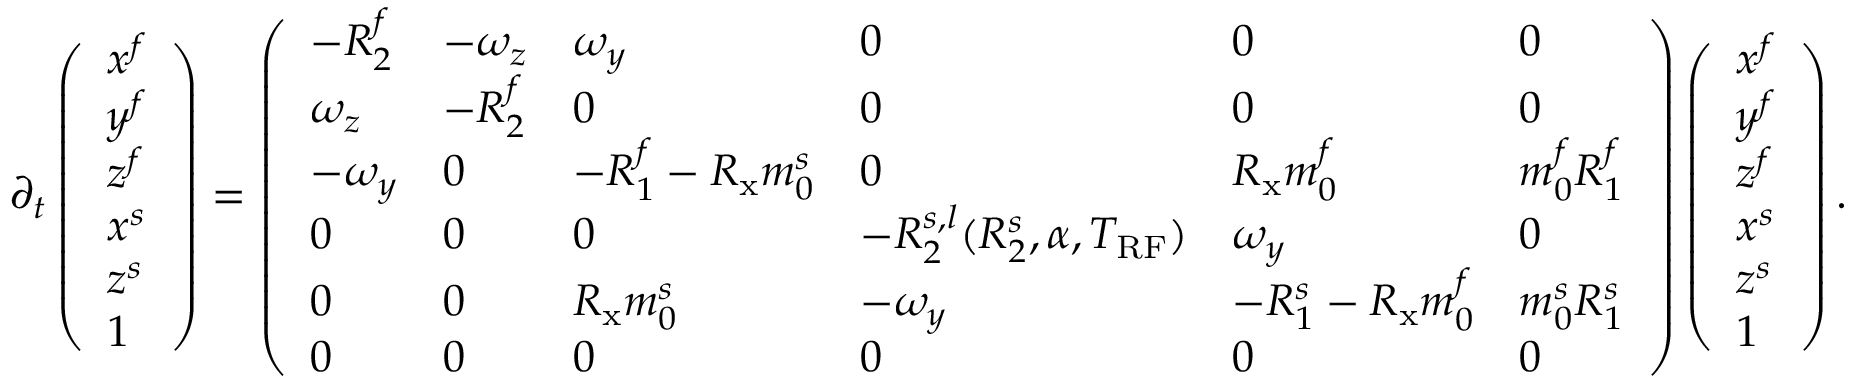Convert formula to latex. <formula><loc_0><loc_0><loc_500><loc_500>\partial _ { t } \left ( \begin{array} { l } { x ^ { f } } \\ { y ^ { f } } \\ { z ^ { f } } \\ { x ^ { s } } \\ { z ^ { s } } \\ { 1 } \end{array} \right ) = \left ( \begin{array} { l l l l l l } { - R _ { 2 } ^ { f } } & { - \omega _ { z } } & { \omega _ { y } } & { 0 } & { 0 } & { 0 } \\ { \omega _ { z } } & { - R _ { 2 } ^ { f } } & { 0 } & { 0 } & { 0 } & { 0 } \\ { - \omega _ { y } } & { 0 } & { - R _ { 1 } ^ { f } - R _ { x } m _ { 0 } ^ { s } } & { 0 } & { R _ { x } m _ { 0 } ^ { f } } & { m _ { 0 } ^ { f } R _ { 1 } ^ { f } } \\ { 0 } & { 0 } & { 0 } & { - R _ { 2 } ^ { s , l } ( R _ { 2 } ^ { s } , \alpha , T _ { R F } ) } & { \omega _ { y } } & { 0 } \\ { 0 } & { 0 } & { R _ { x } m _ { 0 } ^ { s } } & { - \omega _ { y } } & { - R _ { 1 } ^ { s } - R _ { x } m _ { 0 } ^ { f } } & { m _ { 0 } ^ { s } R _ { 1 } ^ { s } } \\ { 0 } & { 0 } & { 0 } & { 0 } & { 0 } & { 0 } \end{array} \right ) \left ( \begin{array} { l } { x ^ { f } } \\ { y ^ { f } } \\ { z ^ { f } } \\ { x ^ { s } } \\ { z ^ { s } } \\ { 1 } \end{array} \right ) .</formula> 